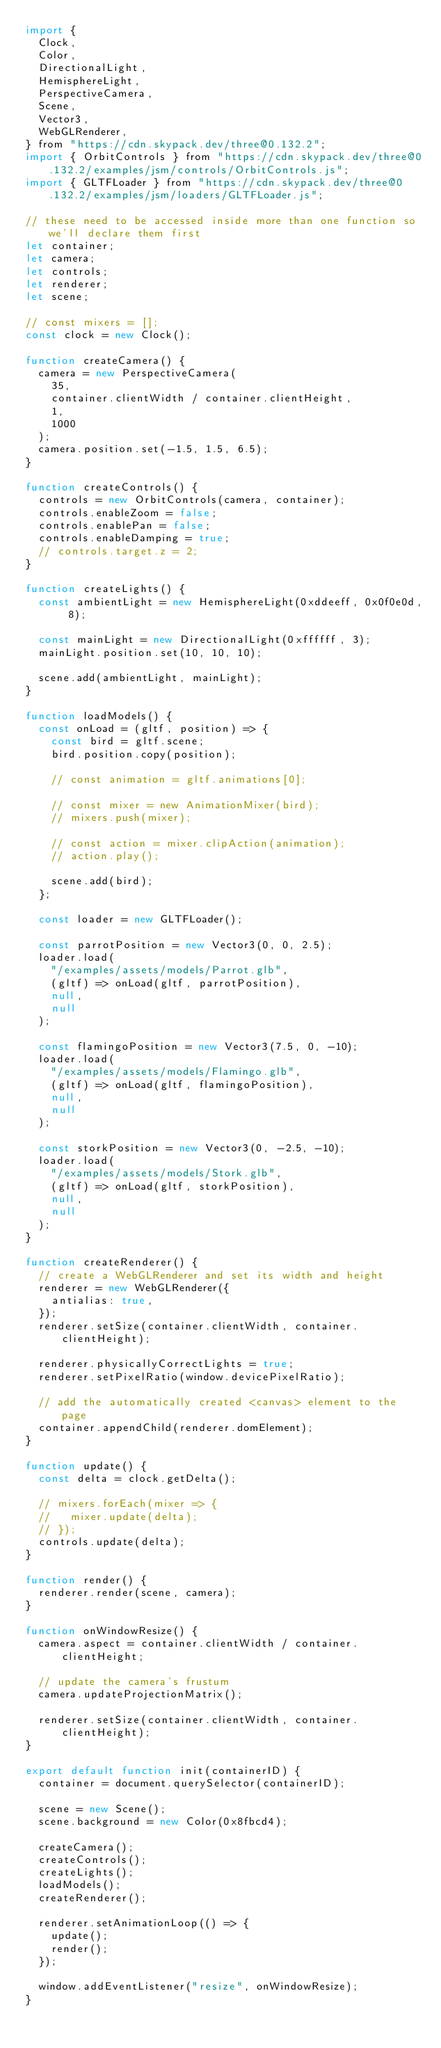<code> <loc_0><loc_0><loc_500><loc_500><_JavaScript_>import {
  Clock,
  Color,
  DirectionalLight,
  HemisphereLight,
  PerspectiveCamera,
  Scene,
  Vector3,
  WebGLRenderer,
} from "https://cdn.skypack.dev/three@0.132.2";
import { OrbitControls } from "https://cdn.skypack.dev/three@0.132.2/examples/jsm/controls/OrbitControls.js";
import { GLTFLoader } from "https://cdn.skypack.dev/three@0.132.2/examples/jsm/loaders/GLTFLoader.js";

// these need to be accessed inside more than one function so we'll declare them first
let container;
let camera;
let controls;
let renderer;
let scene;

// const mixers = [];
const clock = new Clock();

function createCamera() {
  camera = new PerspectiveCamera(
    35,
    container.clientWidth / container.clientHeight,
    1,
    1000
  );
  camera.position.set(-1.5, 1.5, 6.5);
}

function createControls() {
  controls = new OrbitControls(camera, container);
  controls.enableZoom = false;
  controls.enablePan = false;
  controls.enableDamping = true;
  // controls.target.z = 2;
}

function createLights() {
  const ambientLight = new HemisphereLight(0xddeeff, 0x0f0e0d, 8);

  const mainLight = new DirectionalLight(0xffffff, 3);
  mainLight.position.set(10, 10, 10);

  scene.add(ambientLight, mainLight);
}

function loadModels() {
  const onLoad = (gltf, position) => {
    const bird = gltf.scene;
    bird.position.copy(position);

    // const animation = gltf.animations[0];

    // const mixer = new AnimationMixer(bird);
    // mixers.push(mixer);

    // const action = mixer.clipAction(animation);
    // action.play();

    scene.add(bird);
  };

  const loader = new GLTFLoader();

  const parrotPosition = new Vector3(0, 0, 2.5);
  loader.load(
    "/examples/assets/models/Parrot.glb",
    (gltf) => onLoad(gltf, parrotPosition),
    null,
    null
  );

  const flamingoPosition = new Vector3(7.5, 0, -10);
  loader.load(
    "/examples/assets/models/Flamingo.glb",
    (gltf) => onLoad(gltf, flamingoPosition),
    null,
    null
  );

  const storkPosition = new Vector3(0, -2.5, -10);
  loader.load(
    "/examples/assets/models/Stork.glb",
    (gltf) => onLoad(gltf, storkPosition),
    null,
    null
  );
}

function createRenderer() {
  // create a WebGLRenderer and set its width and height
  renderer = new WebGLRenderer({
    antialias: true,
  });
  renderer.setSize(container.clientWidth, container.clientHeight);

  renderer.physicallyCorrectLights = true;
  renderer.setPixelRatio(window.devicePixelRatio);

  // add the automatically created <canvas> element to the page
  container.appendChild(renderer.domElement);
}

function update() {
  const delta = clock.getDelta();

  // mixers.forEach(mixer => {
  //   mixer.update(delta);
  // });
  controls.update(delta);
}

function render() {
  renderer.render(scene, camera);
}

function onWindowResize() {
  camera.aspect = container.clientWidth / container.clientHeight;

  // update the camera's frustum
  camera.updateProjectionMatrix();

  renderer.setSize(container.clientWidth, container.clientHeight);
}

export default function init(containerID) {
  container = document.querySelector(containerID);

  scene = new Scene();
  scene.background = new Color(0x8fbcd4);

  createCamera();
  createControls();
  createLights();
  loadModels();
  createRenderer();

  renderer.setAnimationLoop(() => {
    update();
    render();
  });

  window.addEventListener("resize", onWindowResize);
}
</code> 